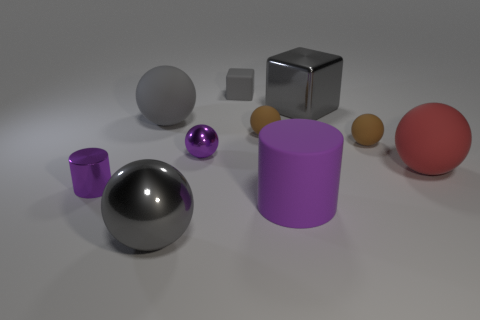What is the large gray thing that is both on the right side of the large gray rubber thing and on the left side of the large gray block made of? metal 